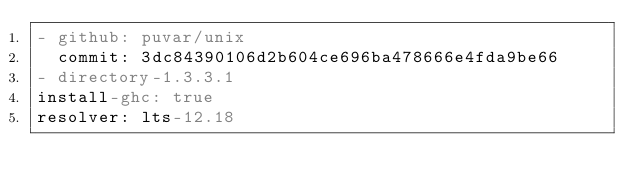Convert code to text. <code><loc_0><loc_0><loc_500><loc_500><_YAML_>- github: puvar/unix
  commit: 3dc84390106d2b604ce696ba478666e4fda9be66
- directory-1.3.3.1
install-ghc: true
resolver: lts-12.18
</code> 